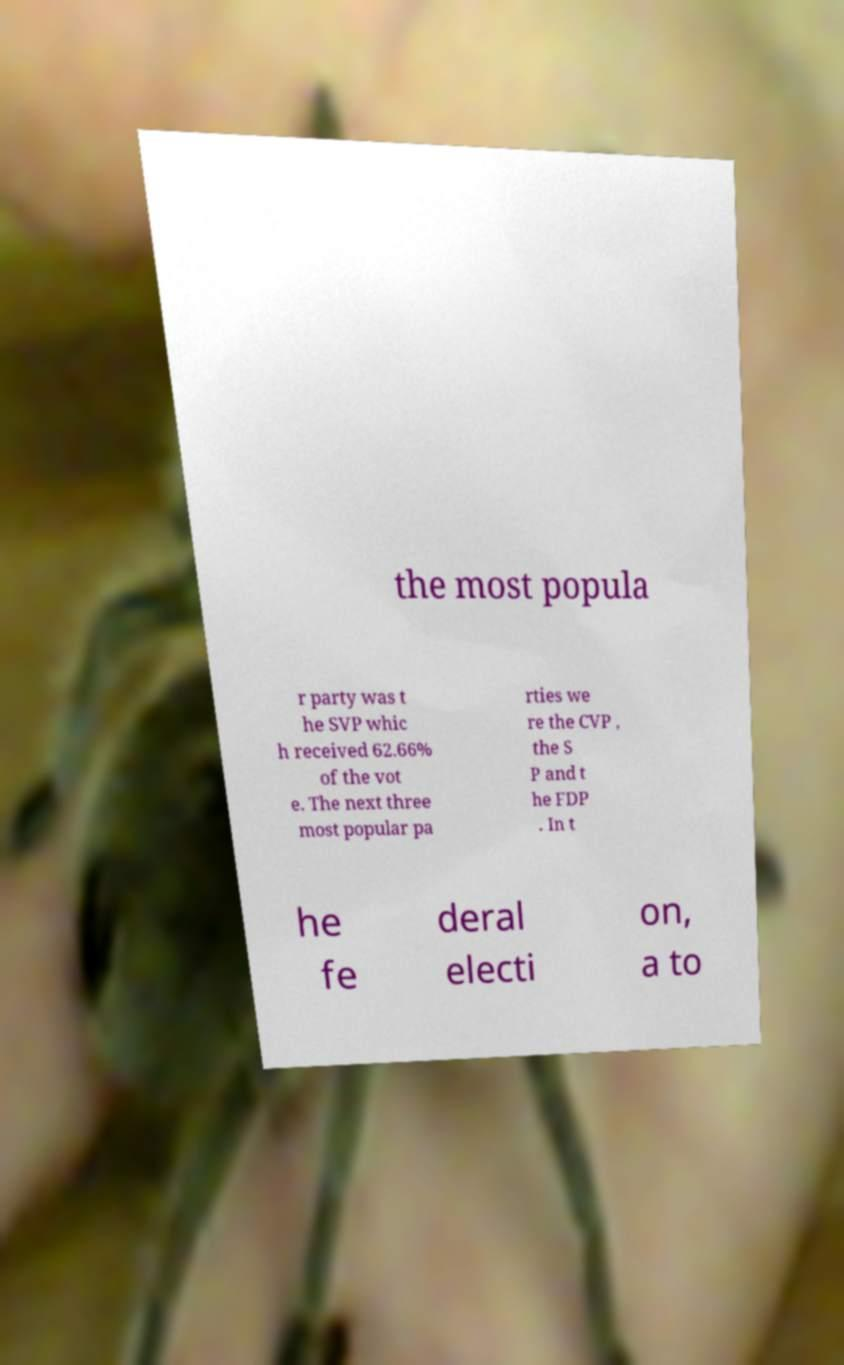For documentation purposes, I need the text within this image transcribed. Could you provide that? the most popula r party was t he SVP whic h received 62.66% of the vot e. The next three most popular pa rties we re the CVP , the S P and t he FDP . In t he fe deral electi on, a to 